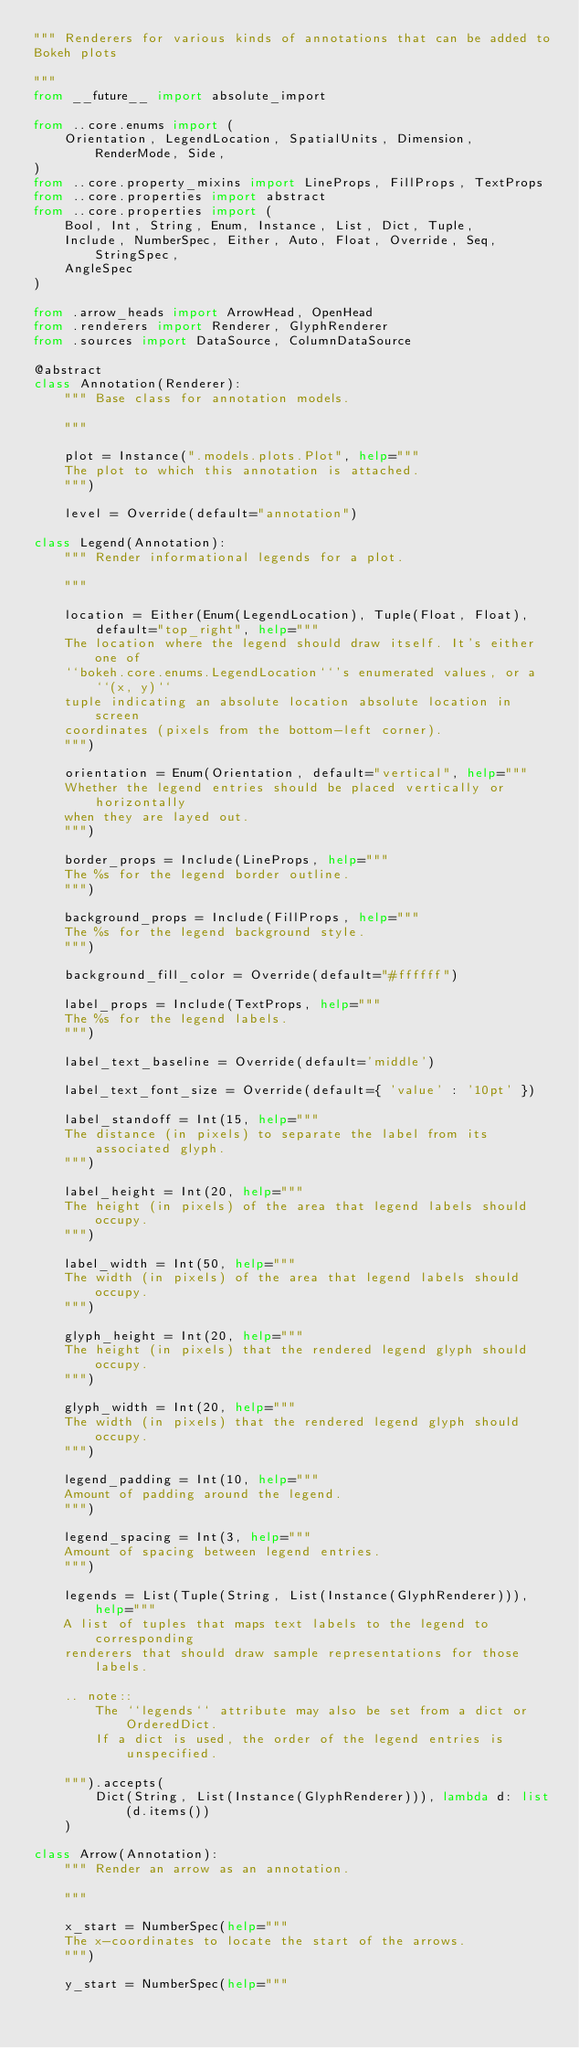Convert code to text. <code><loc_0><loc_0><loc_500><loc_500><_Python_>""" Renderers for various kinds of annotations that can be added to
Bokeh plots

"""
from __future__ import absolute_import

from ..core.enums import (
    Orientation, LegendLocation, SpatialUnits, Dimension, RenderMode, Side,
)
from ..core.property_mixins import LineProps, FillProps, TextProps
from ..core.properties import abstract
from ..core.properties import (
    Bool, Int, String, Enum, Instance, List, Dict, Tuple,
    Include, NumberSpec, Either, Auto, Float, Override, Seq, StringSpec,
    AngleSpec
)

from .arrow_heads import ArrowHead, OpenHead
from .renderers import Renderer, GlyphRenderer
from .sources import DataSource, ColumnDataSource

@abstract
class Annotation(Renderer):
    """ Base class for annotation models.

    """

    plot = Instance(".models.plots.Plot", help="""
    The plot to which this annotation is attached.
    """)

    level = Override(default="annotation")

class Legend(Annotation):
    """ Render informational legends for a plot.

    """

    location = Either(Enum(LegendLocation), Tuple(Float, Float),
        default="top_right", help="""
    The location where the legend should draw itself. It's either one of
    ``bokeh.core.enums.LegendLocation``'s enumerated values, or a ``(x, y)``
    tuple indicating an absolute location absolute location in screen
    coordinates (pixels from the bottom-left corner).
    """)

    orientation = Enum(Orientation, default="vertical", help="""
    Whether the legend entries should be placed vertically or horizontally
    when they are layed out.
    """)

    border_props = Include(LineProps, help="""
    The %s for the legend border outline.
    """)

    background_props = Include(FillProps, help="""
    The %s for the legend background style.
    """)

    background_fill_color = Override(default="#ffffff")

    label_props = Include(TextProps, help="""
    The %s for the legend labels.
    """)

    label_text_baseline = Override(default='middle')

    label_text_font_size = Override(default={ 'value' : '10pt' })

    label_standoff = Int(15, help="""
    The distance (in pixels) to separate the label from its associated glyph.
    """)

    label_height = Int(20, help="""
    The height (in pixels) of the area that legend labels should occupy.
    """)

    label_width = Int(50, help="""
    The width (in pixels) of the area that legend labels should occupy.
    """)

    glyph_height = Int(20, help="""
    The height (in pixels) that the rendered legend glyph should occupy.
    """)

    glyph_width = Int(20, help="""
    The width (in pixels) that the rendered legend glyph should occupy.
    """)

    legend_padding = Int(10, help="""
    Amount of padding around the legend.
    """)

    legend_spacing = Int(3, help="""
    Amount of spacing between legend entries.
    """)

    legends = List(Tuple(String, List(Instance(GlyphRenderer))), help="""
    A list of tuples that maps text labels to the legend to corresponding
    renderers that should draw sample representations for those labels.

    .. note::
        The ``legends`` attribute may also be set from a dict or OrderedDict.
        If a dict is used, the order of the legend entries is unspecified.

    """).accepts(
        Dict(String, List(Instance(GlyphRenderer))), lambda d: list(d.items())
    )

class Arrow(Annotation):
    """ Render an arrow as an annotation.

    """

    x_start = NumberSpec(help="""
    The x-coordinates to locate the start of the arrows.
    """)

    y_start = NumberSpec(help="""</code> 